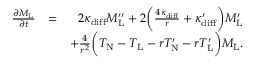Convert formula to latex. <formula><loc_0><loc_0><loc_500><loc_500>\begin{array} { r l r } { \frac { \partial M _ { L } } { \partial t } } & { = } & { 2 \kappa _ { d i f f } M _ { L } ^ { \prime \prime } + 2 \left ( \frac { 4 \kappa _ { d i f f } } { r } + \kappa _ { d i f f } ^ { \prime } \right ) M _ { L } ^ { \prime } } \\ & { + \frac { 4 } { r ^ { 2 } } \left ( T _ { N } - T _ { L } - r T _ { N } ^ { \prime } - r T _ { L } ^ { \prime } \right ) M _ { L } . } \end{array}</formula> 